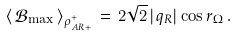<formula> <loc_0><loc_0><loc_500><loc_500>\left \langle \, \mathcal { B } _ { \max } \, \right \rangle _ { \rho ^ { + } _ { A R + } } \, = \, 2 \sqrt { 2 } \, | q _ { R } | \cos r _ { \Omega } \, .</formula> 